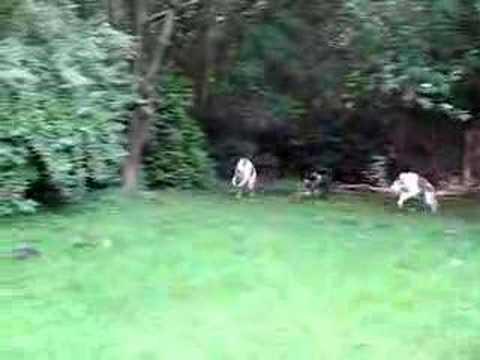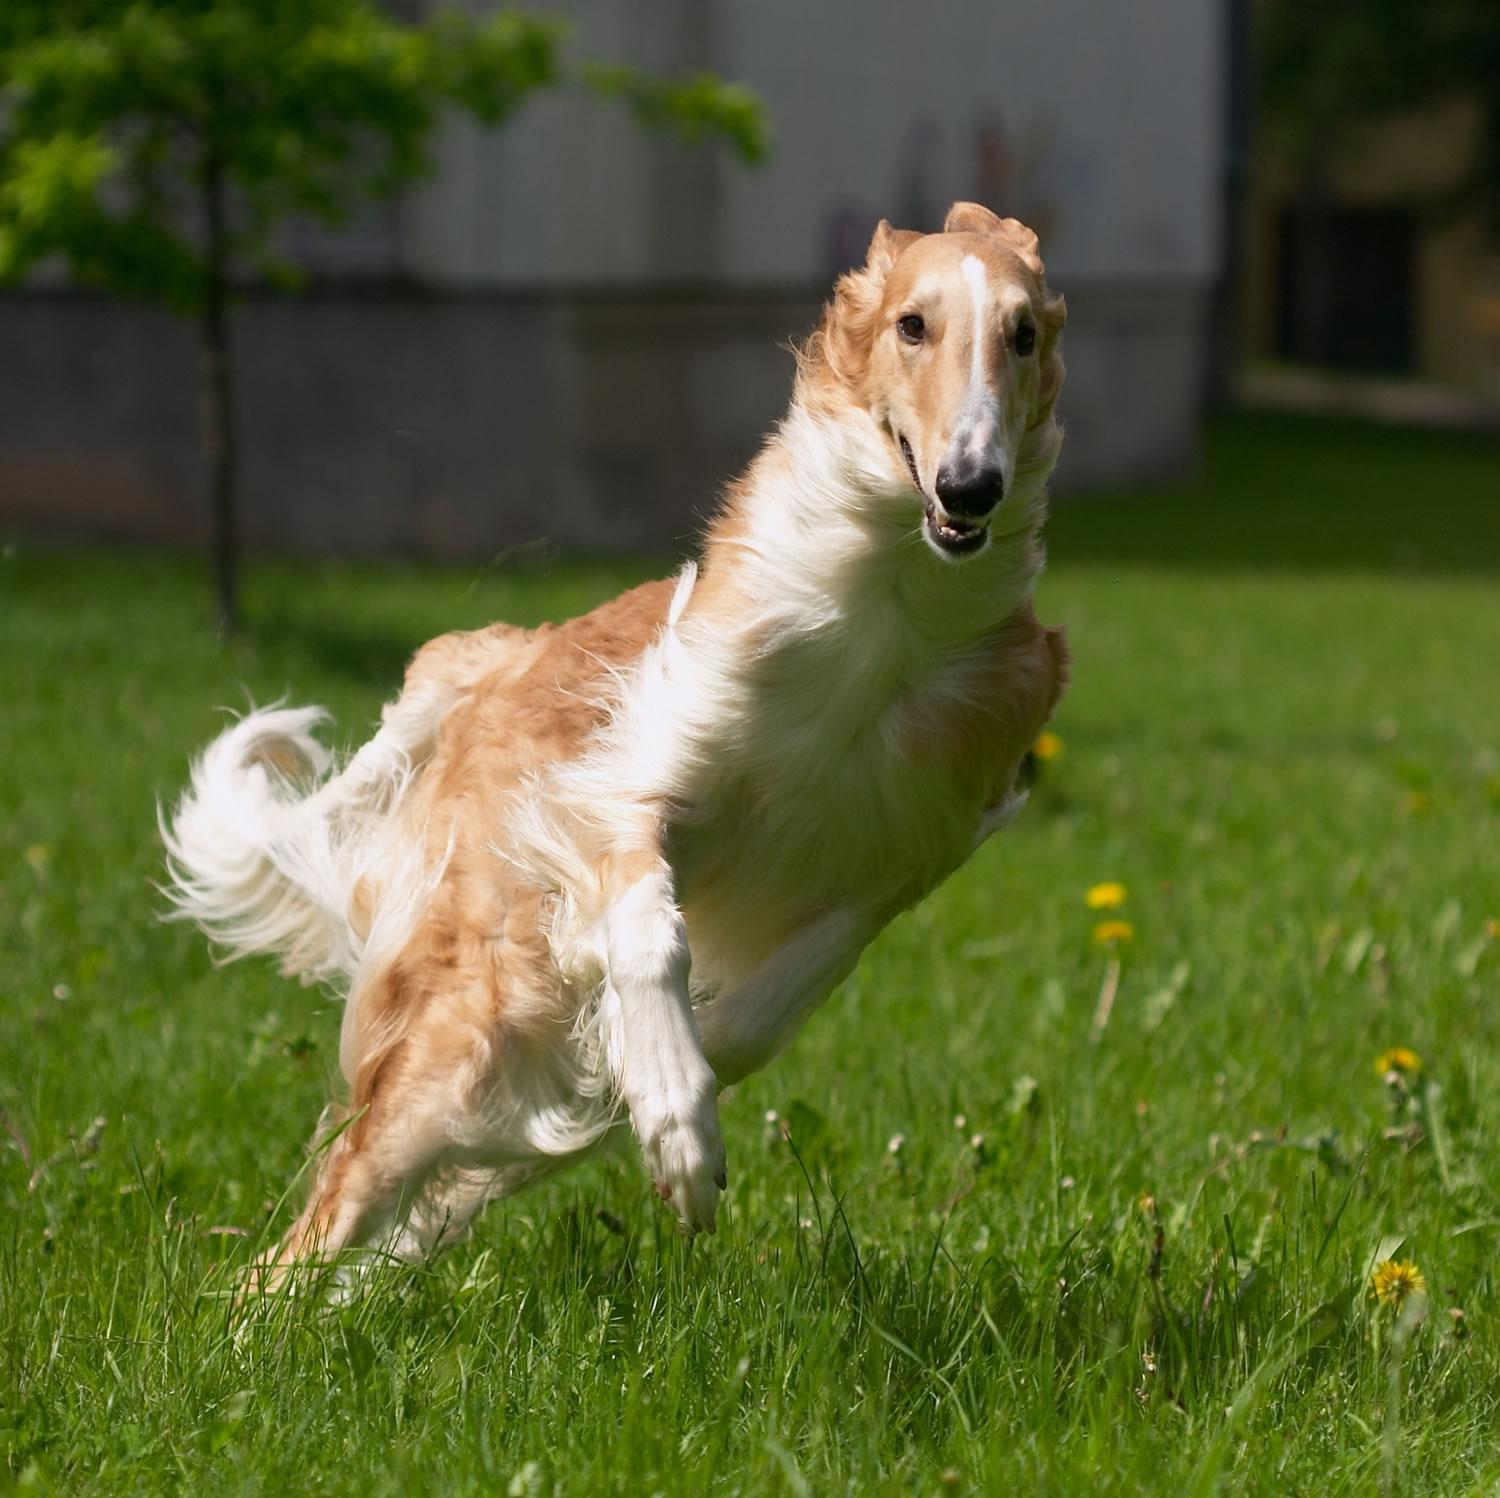The first image is the image on the left, the second image is the image on the right. Considering the images on both sides, is "Each image includes bounding hounds, and the right image shows a hound with its body leaning to the right as it runs forward." valid? Answer yes or no. Yes. The first image is the image on the left, the second image is the image on the right. Evaluate the accuracy of this statement regarding the images: "At least one dog has its front paws off the ground.". Is it true? Answer yes or no. Yes. 